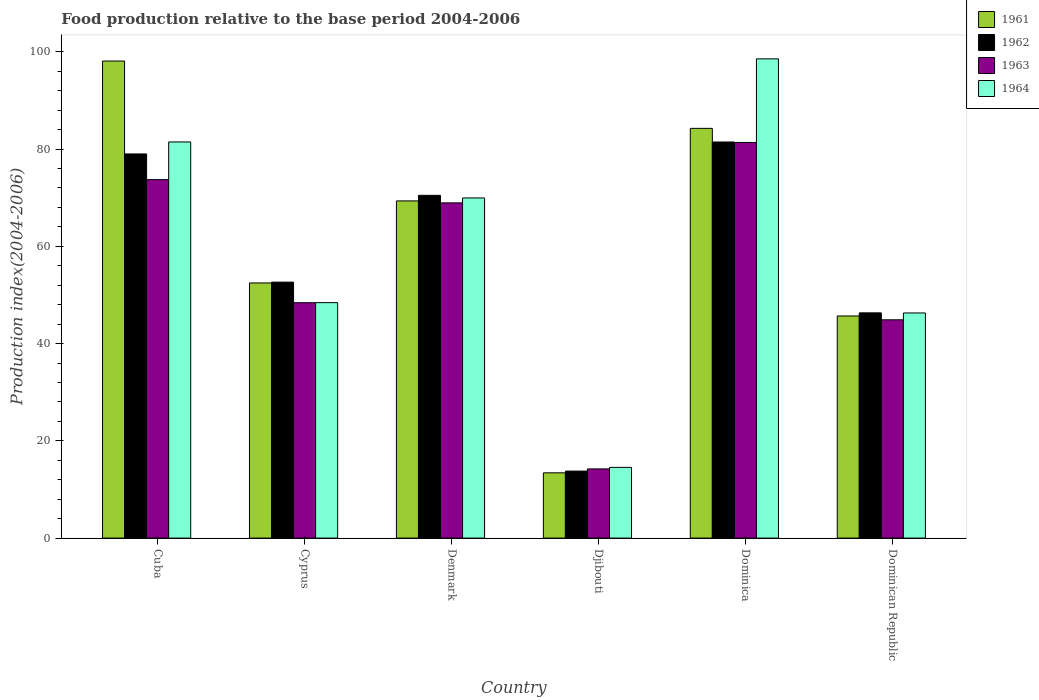How many groups of bars are there?
Offer a very short reply. 6. Are the number of bars per tick equal to the number of legend labels?
Provide a short and direct response. Yes. Are the number of bars on each tick of the X-axis equal?
Provide a short and direct response. Yes. How many bars are there on the 4th tick from the right?
Make the answer very short. 4. What is the label of the 1st group of bars from the left?
Offer a terse response. Cuba. In how many cases, is the number of bars for a given country not equal to the number of legend labels?
Provide a short and direct response. 0. What is the food production index in 1964 in Dominican Republic?
Your answer should be compact. 46.3. Across all countries, what is the maximum food production index in 1962?
Offer a terse response. 81.46. Across all countries, what is the minimum food production index in 1962?
Ensure brevity in your answer.  13.78. In which country was the food production index in 1964 maximum?
Offer a terse response. Dominica. In which country was the food production index in 1961 minimum?
Provide a short and direct response. Djibouti. What is the total food production index in 1962 in the graph?
Your answer should be very brief. 343.69. What is the difference between the food production index in 1961 in Cuba and that in Djibouti?
Your answer should be compact. 84.69. What is the difference between the food production index in 1963 in Dominican Republic and the food production index in 1964 in Cuba?
Make the answer very short. -36.58. What is the average food production index in 1964 per country?
Make the answer very short. 59.87. What is the difference between the food production index of/in 1962 and food production index of/in 1961 in Dominican Republic?
Offer a terse response. 0.64. In how many countries, is the food production index in 1961 greater than 96?
Your answer should be compact. 1. What is the ratio of the food production index in 1963 in Cuba to that in Djibouti?
Ensure brevity in your answer.  5.18. Is the food production index in 1963 in Denmark less than that in Djibouti?
Provide a short and direct response. No. What is the difference between the highest and the second highest food production index in 1962?
Offer a very short reply. 10.97. What is the difference between the highest and the lowest food production index in 1964?
Provide a short and direct response. 84.02. Is it the case that in every country, the sum of the food production index in 1961 and food production index in 1963 is greater than the sum of food production index in 1964 and food production index in 1962?
Your response must be concise. No. Is it the case that in every country, the sum of the food production index in 1964 and food production index in 1961 is greater than the food production index in 1963?
Offer a very short reply. Yes. How many countries are there in the graph?
Your answer should be compact. 6. What is the difference between two consecutive major ticks on the Y-axis?
Ensure brevity in your answer.  20. Are the values on the major ticks of Y-axis written in scientific E-notation?
Offer a very short reply. No. How are the legend labels stacked?
Offer a very short reply. Vertical. What is the title of the graph?
Provide a succinct answer. Food production relative to the base period 2004-2006. Does "1990" appear as one of the legend labels in the graph?
Offer a terse response. No. What is the label or title of the X-axis?
Make the answer very short. Country. What is the label or title of the Y-axis?
Offer a terse response. Production index(2004-2006). What is the Production index(2004-2006) in 1961 in Cuba?
Make the answer very short. 98.11. What is the Production index(2004-2006) in 1962 in Cuba?
Provide a succinct answer. 79. What is the Production index(2004-2006) in 1963 in Cuba?
Offer a terse response. 73.72. What is the Production index(2004-2006) in 1964 in Cuba?
Offer a very short reply. 81.47. What is the Production index(2004-2006) in 1961 in Cyprus?
Give a very brief answer. 52.47. What is the Production index(2004-2006) of 1962 in Cyprus?
Provide a short and direct response. 52.64. What is the Production index(2004-2006) of 1963 in Cyprus?
Make the answer very short. 48.41. What is the Production index(2004-2006) of 1964 in Cyprus?
Your response must be concise. 48.42. What is the Production index(2004-2006) in 1961 in Denmark?
Give a very brief answer. 69.34. What is the Production index(2004-2006) of 1962 in Denmark?
Make the answer very short. 70.49. What is the Production index(2004-2006) in 1963 in Denmark?
Offer a very short reply. 68.94. What is the Production index(2004-2006) in 1964 in Denmark?
Provide a succinct answer. 69.95. What is the Production index(2004-2006) in 1961 in Djibouti?
Make the answer very short. 13.42. What is the Production index(2004-2006) in 1962 in Djibouti?
Give a very brief answer. 13.78. What is the Production index(2004-2006) in 1963 in Djibouti?
Offer a very short reply. 14.23. What is the Production index(2004-2006) in 1964 in Djibouti?
Provide a short and direct response. 14.54. What is the Production index(2004-2006) in 1961 in Dominica?
Ensure brevity in your answer.  84.26. What is the Production index(2004-2006) in 1962 in Dominica?
Make the answer very short. 81.46. What is the Production index(2004-2006) of 1963 in Dominica?
Ensure brevity in your answer.  81.36. What is the Production index(2004-2006) in 1964 in Dominica?
Keep it short and to the point. 98.56. What is the Production index(2004-2006) of 1961 in Dominican Republic?
Give a very brief answer. 45.68. What is the Production index(2004-2006) in 1962 in Dominican Republic?
Provide a succinct answer. 46.32. What is the Production index(2004-2006) in 1963 in Dominican Republic?
Give a very brief answer. 44.89. What is the Production index(2004-2006) of 1964 in Dominican Republic?
Give a very brief answer. 46.3. Across all countries, what is the maximum Production index(2004-2006) in 1961?
Your answer should be very brief. 98.11. Across all countries, what is the maximum Production index(2004-2006) in 1962?
Your answer should be compact. 81.46. Across all countries, what is the maximum Production index(2004-2006) in 1963?
Provide a short and direct response. 81.36. Across all countries, what is the maximum Production index(2004-2006) in 1964?
Offer a very short reply. 98.56. Across all countries, what is the minimum Production index(2004-2006) in 1961?
Keep it short and to the point. 13.42. Across all countries, what is the minimum Production index(2004-2006) of 1962?
Ensure brevity in your answer.  13.78. Across all countries, what is the minimum Production index(2004-2006) of 1963?
Keep it short and to the point. 14.23. Across all countries, what is the minimum Production index(2004-2006) in 1964?
Your answer should be compact. 14.54. What is the total Production index(2004-2006) in 1961 in the graph?
Make the answer very short. 363.28. What is the total Production index(2004-2006) in 1962 in the graph?
Make the answer very short. 343.69. What is the total Production index(2004-2006) in 1963 in the graph?
Your answer should be compact. 331.55. What is the total Production index(2004-2006) of 1964 in the graph?
Offer a terse response. 359.24. What is the difference between the Production index(2004-2006) in 1961 in Cuba and that in Cyprus?
Keep it short and to the point. 45.64. What is the difference between the Production index(2004-2006) in 1962 in Cuba and that in Cyprus?
Ensure brevity in your answer.  26.36. What is the difference between the Production index(2004-2006) of 1963 in Cuba and that in Cyprus?
Ensure brevity in your answer.  25.31. What is the difference between the Production index(2004-2006) of 1964 in Cuba and that in Cyprus?
Offer a terse response. 33.05. What is the difference between the Production index(2004-2006) of 1961 in Cuba and that in Denmark?
Offer a terse response. 28.77. What is the difference between the Production index(2004-2006) in 1962 in Cuba and that in Denmark?
Provide a short and direct response. 8.51. What is the difference between the Production index(2004-2006) of 1963 in Cuba and that in Denmark?
Ensure brevity in your answer.  4.78. What is the difference between the Production index(2004-2006) in 1964 in Cuba and that in Denmark?
Make the answer very short. 11.52. What is the difference between the Production index(2004-2006) of 1961 in Cuba and that in Djibouti?
Your response must be concise. 84.69. What is the difference between the Production index(2004-2006) of 1962 in Cuba and that in Djibouti?
Your response must be concise. 65.22. What is the difference between the Production index(2004-2006) of 1963 in Cuba and that in Djibouti?
Your response must be concise. 59.49. What is the difference between the Production index(2004-2006) in 1964 in Cuba and that in Djibouti?
Offer a very short reply. 66.93. What is the difference between the Production index(2004-2006) in 1961 in Cuba and that in Dominica?
Offer a terse response. 13.85. What is the difference between the Production index(2004-2006) of 1962 in Cuba and that in Dominica?
Your answer should be compact. -2.46. What is the difference between the Production index(2004-2006) of 1963 in Cuba and that in Dominica?
Make the answer very short. -7.64. What is the difference between the Production index(2004-2006) of 1964 in Cuba and that in Dominica?
Your answer should be very brief. -17.09. What is the difference between the Production index(2004-2006) of 1961 in Cuba and that in Dominican Republic?
Provide a short and direct response. 52.43. What is the difference between the Production index(2004-2006) of 1962 in Cuba and that in Dominican Republic?
Keep it short and to the point. 32.68. What is the difference between the Production index(2004-2006) in 1963 in Cuba and that in Dominican Republic?
Make the answer very short. 28.83. What is the difference between the Production index(2004-2006) of 1964 in Cuba and that in Dominican Republic?
Your answer should be compact. 35.17. What is the difference between the Production index(2004-2006) of 1961 in Cyprus and that in Denmark?
Make the answer very short. -16.87. What is the difference between the Production index(2004-2006) of 1962 in Cyprus and that in Denmark?
Your answer should be very brief. -17.85. What is the difference between the Production index(2004-2006) of 1963 in Cyprus and that in Denmark?
Ensure brevity in your answer.  -20.53. What is the difference between the Production index(2004-2006) in 1964 in Cyprus and that in Denmark?
Offer a terse response. -21.53. What is the difference between the Production index(2004-2006) in 1961 in Cyprus and that in Djibouti?
Ensure brevity in your answer.  39.05. What is the difference between the Production index(2004-2006) in 1962 in Cyprus and that in Djibouti?
Give a very brief answer. 38.86. What is the difference between the Production index(2004-2006) of 1963 in Cyprus and that in Djibouti?
Keep it short and to the point. 34.18. What is the difference between the Production index(2004-2006) of 1964 in Cyprus and that in Djibouti?
Your answer should be compact. 33.88. What is the difference between the Production index(2004-2006) in 1961 in Cyprus and that in Dominica?
Keep it short and to the point. -31.79. What is the difference between the Production index(2004-2006) of 1962 in Cyprus and that in Dominica?
Provide a short and direct response. -28.82. What is the difference between the Production index(2004-2006) in 1963 in Cyprus and that in Dominica?
Your answer should be very brief. -32.95. What is the difference between the Production index(2004-2006) of 1964 in Cyprus and that in Dominica?
Keep it short and to the point. -50.14. What is the difference between the Production index(2004-2006) of 1961 in Cyprus and that in Dominican Republic?
Your answer should be compact. 6.79. What is the difference between the Production index(2004-2006) in 1962 in Cyprus and that in Dominican Republic?
Give a very brief answer. 6.32. What is the difference between the Production index(2004-2006) in 1963 in Cyprus and that in Dominican Republic?
Your answer should be very brief. 3.52. What is the difference between the Production index(2004-2006) in 1964 in Cyprus and that in Dominican Republic?
Your response must be concise. 2.12. What is the difference between the Production index(2004-2006) in 1961 in Denmark and that in Djibouti?
Provide a short and direct response. 55.92. What is the difference between the Production index(2004-2006) in 1962 in Denmark and that in Djibouti?
Provide a succinct answer. 56.71. What is the difference between the Production index(2004-2006) in 1963 in Denmark and that in Djibouti?
Offer a terse response. 54.71. What is the difference between the Production index(2004-2006) of 1964 in Denmark and that in Djibouti?
Offer a terse response. 55.41. What is the difference between the Production index(2004-2006) in 1961 in Denmark and that in Dominica?
Make the answer very short. -14.92. What is the difference between the Production index(2004-2006) in 1962 in Denmark and that in Dominica?
Provide a succinct answer. -10.97. What is the difference between the Production index(2004-2006) of 1963 in Denmark and that in Dominica?
Offer a terse response. -12.42. What is the difference between the Production index(2004-2006) of 1964 in Denmark and that in Dominica?
Your response must be concise. -28.61. What is the difference between the Production index(2004-2006) in 1961 in Denmark and that in Dominican Republic?
Keep it short and to the point. 23.66. What is the difference between the Production index(2004-2006) in 1962 in Denmark and that in Dominican Republic?
Keep it short and to the point. 24.17. What is the difference between the Production index(2004-2006) of 1963 in Denmark and that in Dominican Republic?
Offer a terse response. 24.05. What is the difference between the Production index(2004-2006) in 1964 in Denmark and that in Dominican Republic?
Offer a very short reply. 23.65. What is the difference between the Production index(2004-2006) of 1961 in Djibouti and that in Dominica?
Provide a short and direct response. -70.84. What is the difference between the Production index(2004-2006) of 1962 in Djibouti and that in Dominica?
Ensure brevity in your answer.  -67.68. What is the difference between the Production index(2004-2006) in 1963 in Djibouti and that in Dominica?
Make the answer very short. -67.13. What is the difference between the Production index(2004-2006) in 1964 in Djibouti and that in Dominica?
Your answer should be very brief. -84.02. What is the difference between the Production index(2004-2006) of 1961 in Djibouti and that in Dominican Republic?
Provide a succinct answer. -32.26. What is the difference between the Production index(2004-2006) in 1962 in Djibouti and that in Dominican Republic?
Your response must be concise. -32.54. What is the difference between the Production index(2004-2006) in 1963 in Djibouti and that in Dominican Republic?
Ensure brevity in your answer.  -30.66. What is the difference between the Production index(2004-2006) of 1964 in Djibouti and that in Dominican Republic?
Make the answer very short. -31.76. What is the difference between the Production index(2004-2006) in 1961 in Dominica and that in Dominican Republic?
Ensure brevity in your answer.  38.58. What is the difference between the Production index(2004-2006) of 1962 in Dominica and that in Dominican Republic?
Give a very brief answer. 35.14. What is the difference between the Production index(2004-2006) of 1963 in Dominica and that in Dominican Republic?
Your response must be concise. 36.47. What is the difference between the Production index(2004-2006) of 1964 in Dominica and that in Dominican Republic?
Your answer should be very brief. 52.26. What is the difference between the Production index(2004-2006) of 1961 in Cuba and the Production index(2004-2006) of 1962 in Cyprus?
Offer a very short reply. 45.47. What is the difference between the Production index(2004-2006) of 1961 in Cuba and the Production index(2004-2006) of 1963 in Cyprus?
Provide a short and direct response. 49.7. What is the difference between the Production index(2004-2006) of 1961 in Cuba and the Production index(2004-2006) of 1964 in Cyprus?
Give a very brief answer. 49.69. What is the difference between the Production index(2004-2006) in 1962 in Cuba and the Production index(2004-2006) in 1963 in Cyprus?
Provide a succinct answer. 30.59. What is the difference between the Production index(2004-2006) of 1962 in Cuba and the Production index(2004-2006) of 1964 in Cyprus?
Make the answer very short. 30.58. What is the difference between the Production index(2004-2006) of 1963 in Cuba and the Production index(2004-2006) of 1964 in Cyprus?
Ensure brevity in your answer.  25.3. What is the difference between the Production index(2004-2006) of 1961 in Cuba and the Production index(2004-2006) of 1962 in Denmark?
Give a very brief answer. 27.62. What is the difference between the Production index(2004-2006) in 1961 in Cuba and the Production index(2004-2006) in 1963 in Denmark?
Keep it short and to the point. 29.17. What is the difference between the Production index(2004-2006) in 1961 in Cuba and the Production index(2004-2006) in 1964 in Denmark?
Provide a short and direct response. 28.16. What is the difference between the Production index(2004-2006) in 1962 in Cuba and the Production index(2004-2006) in 1963 in Denmark?
Give a very brief answer. 10.06. What is the difference between the Production index(2004-2006) in 1962 in Cuba and the Production index(2004-2006) in 1964 in Denmark?
Your response must be concise. 9.05. What is the difference between the Production index(2004-2006) of 1963 in Cuba and the Production index(2004-2006) of 1964 in Denmark?
Provide a short and direct response. 3.77. What is the difference between the Production index(2004-2006) of 1961 in Cuba and the Production index(2004-2006) of 1962 in Djibouti?
Your answer should be compact. 84.33. What is the difference between the Production index(2004-2006) of 1961 in Cuba and the Production index(2004-2006) of 1963 in Djibouti?
Ensure brevity in your answer.  83.88. What is the difference between the Production index(2004-2006) in 1961 in Cuba and the Production index(2004-2006) in 1964 in Djibouti?
Your answer should be compact. 83.57. What is the difference between the Production index(2004-2006) in 1962 in Cuba and the Production index(2004-2006) in 1963 in Djibouti?
Your answer should be compact. 64.77. What is the difference between the Production index(2004-2006) in 1962 in Cuba and the Production index(2004-2006) in 1964 in Djibouti?
Your answer should be very brief. 64.46. What is the difference between the Production index(2004-2006) of 1963 in Cuba and the Production index(2004-2006) of 1964 in Djibouti?
Your answer should be compact. 59.18. What is the difference between the Production index(2004-2006) of 1961 in Cuba and the Production index(2004-2006) of 1962 in Dominica?
Your answer should be compact. 16.65. What is the difference between the Production index(2004-2006) of 1961 in Cuba and the Production index(2004-2006) of 1963 in Dominica?
Ensure brevity in your answer.  16.75. What is the difference between the Production index(2004-2006) of 1961 in Cuba and the Production index(2004-2006) of 1964 in Dominica?
Your response must be concise. -0.45. What is the difference between the Production index(2004-2006) of 1962 in Cuba and the Production index(2004-2006) of 1963 in Dominica?
Your answer should be very brief. -2.36. What is the difference between the Production index(2004-2006) in 1962 in Cuba and the Production index(2004-2006) in 1964 in Dominica?
Your answer should be very brief. -19.56. What is the difference between the Production index(2004-2006) of 1963 in Cuba and the Production index(2004-2006) of 1964 in Dominica?
Your answer should be very brief. -24.84. What is the difference between the Production index(2004-2006) in 1961 in Cuba and the Production index(2004-2006) in 1962 in Dominican Republic?
Your response must be concise. 51.79. What is the difference between the Production index(2004-2006) in 1961 in Cuba and the Production index(2004-2006) in 1963 in Dominican Republic?
Give a very brief answer. 53.22. What is the difference between the Production index(2004-2006) in 1961 in Cuba and the Production index(2004-2006) in 1964 in Dominican Republic?
Make the answer very short. 51.81. What is the difference between the Production index(2004-2006) in 1962 in Cuba and the Production index(2004-2006) in 1963 in Dominican Republic?
Ensure brevity in your answer.  34.11. What is the difference between the Production index(2004-2006) of 1962 in Cuba and the Production index(2004-2006) of 1964 in Dominican Republic?
Give a very brief answer. 32.7. What is the difference between the Production index(2004-2006) in 1963 in Cuba and the Production index(2004-2006) in 1964 in Dominican Republic?
Ensure brevity in your answer.  27.42. What is the difference between the Production index(2004-2006) in 1961 in Cyprus and the Production index(2004-2006) in 1962 in Denmark?
Your answer should be compact. -18.02. What is the difference between the Production index(2004-2006) in 1961 in Cyprus and the Production index(2004-2006) in 1963 in Denmark?
Your response must be concise. -16.47. What is the difference between the Production index(2004-2006) of 1961 in Cyprus and the Production index(2004-2006) of 1964 in Denmark?
Provide a succinct answer. -17.48. What is the difference between the Production index(2004-2006) in 1962 in Cyprus and the Production index(2004-2006) in 1963 in Denmark?
Ensure brevity in your answer.  -16.3. What is the difference between the Production index(2004-2006) of 1962 in Cyprus and the Production index(2004-2006) of 1964 in Denmark?
Your answer should be compact. -17.31. What is the difference between the Production index(2004-2006) in 1963 in Cyprus and the Production index(2004-2006) in 1964 in Denmark?
Offer a terse response. -21.54. What is the difference between the Production index(2004-2006) in 1961 in Cyprus and the Production index(2004-2006) in 1962 in Djibouti?
Your response must be concise. 38.69. What is the difference between the Production index(2004-2006) in 1961 in Cyprus and the Production index(2004-2006) in 1963 in Djibouti?
Make the answer very short. 38.24. What is the difference between the Production index(2004-2006) of 1961 in Cyprus and the Production index(2004-2006) of 1964 in Djibouti?
Ensure brevity in your answer.  37.93. What is the difference between the Production index(2004-2006) of 1962 in Cyprus and the Production index(2004-2006) of 1963 in Djibouti?
Provide a short and direct response. 38.41. What is the difference between the Production index(2004-2006) of 1962 in Cyprus and the Production index(2004-2006) of 1964 in Djibouti?
Give a very brief answer. 38.1. What is the difference between the Production index(2004-2006) of 1963 in Cyprus and the Production index(2004-2006) of 1964 in Djibouti?
Offer a very short reply. 33.87. What is the difference between the Production index(2004-2006) of 1961 in Cyprus and the Production index(2004-2006) of 1962 in Dominica?
Your answer should be very brief. -28.99. What is the difference between the Production index(2004-2006) in 1961 in Cyprus and the Production index(2004-2006) in 1963 in Dominica?
Your answer should be very brief. -28.89. What is the difference between the Production index(2004-2006) in 1961 in Cyprus and the Production index(2004-2006) in 1964 in Dominica?
Your response must be concise. -46.09. What is the difference between the Production index(2004-2006) of 1962 in Cyprus and the Production index(2004-2006) of 1963 in Dominica?
Your response must be concise. -28.72. What is the difference between the Production index(2004-2006) in 1962 in Cyprus and the Production index(2004-2006) in 1964 in Dominica?
Provide a short and direct response. -45.92. What is the difference between the Production index(2004-2006) in 1963 in Cyprus and the Production index(2004-2006) in 1964 in Dominica?
Your answer should be very brief. -50.15. What is the difference between the Production index(2004-2006) in 1961 in Cyprus and the Production index(2004-2006) in 1962 in Dominican Republic?
Your response must be concise. 6.15. What is the difference between the Production index(2004-2006) of 1961 in Cyprus and the Production index(2004-2006) of 1963 in Dominican Republic?
Your answer should be compact. 7.58. What is the difference between the Production index(2004-2006) of 1961 in Cyprus and the Production index(2004-2006) of 1964 in Dominican Republic?
Ensure brevity in your answer.  6.17. What is the difference between the Production index(2004-2006) in 1962 in Cyprus and the Production index(2004-2006) in 1963 in Dominican Republic?
Offer a terse response. 7.75. What is the difference between the Production index(2004-2006) in 1962 in Cyprus and the Production index(2004-2006) in 1964 in Dominican Republic?
Ensure brevity in your answer.  6.34. What is the difference between the Production index(2004-2006) in 1963 in Cyprus and the Production index(2004-2006) in 1964 in Dominican Republic?
Your answer should be compact. 2.11. What is the difference between the Production index(2004-2006) of 1961 in Denmark and the Production index(2004-2006) of 1962 in Djibouti?
Your answer should be very brief. 55.56. What is the difference between the Production index(2004-2006) in 1961 in Denmark and the Production index(2004-2006) in 1963 in Djibouti?
Your answer should be compact. 55.11. What is the difference between the Production index(2004-2006) of 1961 in Denmark and the Production index(2004-2006) of 1964 in Djibouti?
Provide a succinct answer. 54.8. What is the difference between the Production index(2004-2006) in 1962 in Denmark and the Production index(2004-2006) in 1963 in Djibouti?
Your answer should be very brief. 56.26. What is the difference between the Production index(2004-2006) of 1962 in Denmark and the Production index(2004-2006) of 1964 in Djibouti?
Your answer should be very brief. 55.95. What is the difference between the Production index(2004-2006) in 1963 in Denmark and the Production index(2004-2006) in 1964 in Djibouti?
Provide a short and direct response. 54.4. What is the difference between the Production index(2004-2006) in 1961 in Denmark and the Production index(2004-2006) in 1962 in Dominica?
Your response must be concise. -12.12. What is the difference between the Production index(2004-2006) in 1961 in Denmark and the Production index(2004-2006) in 1963 in Dominica?
Make the answer very short. -12.02. What is the difference between the Production index(2004-2006) of 1961 in Denmark and the Production index(2004-2006) of 1964 in Dominica?
Give a very brief answer. -29.22. What is the difference between the Production index(2004-2006) in 1962 in Denmark and the Production index(2004-2006) in 1963 in Dominica?
Keep it short and to the point. -10.87. What is the difference between the Production index(2004-2006) in 1962 in Denmark and the Production index(2004-2006) in 1964 in Dominica?
Offer a very short reply. -28.07. What is the difference between the Production index(2004-2006) in 1963 in Denmark and the Production index(2004-2006) in 1964 in Dominica?
Ensure brevity in your answer.  -29.62. What is the difference between the Production index(2004-2006) in 1961 in Denmark and the Production index(2004-2006) in 1962 in Dominican Republic?
Your response must be concise. 23.02. What is the difference between the Production index(2004-2006) in 1961 in Denmark and the Production index(2004-2006) in 1963 in Dominican Republic?
Ensure brevity in your answer.  24.45. What is the difference between the Production index(2004-2006) in 1961 in Denmark and the Production index(2004-2006) in 1964 in Dominican Republic?
Your response must be concise. 23.04. What is the difference between the Production index(2004-2006) of 1962 in Denmark and the Production index(2004-2006) of 1963 in Dominican Republic?
Make the answer very short. 25.6. What is the difference between the Production index(2004-2006) of 1962 in Denmark and the Production index(2004-2006) of 1964 in Dominican Republic?
Offer a very short reply. 24.19. What is the difference between the Production index(2004-2006) in 1963 in Denmark and the Production index(2004-2006) in 1964 in Dominican Republic?
Your answer should be very brief. 22.64. What is the difference between the Production index(2004-2006) of 1961 in Djibouti and the Production index(2004-2006) of 1962 in Dominica?
Offer a terse response. -68.04. What is the difference between the Production index(2004-2006) of 1961 in Djibouti and the Production index(2004-2006) of 1963 in Dominica?
Make the answer very short. -67.94. What is the difference between the Production index(2004-2006) in 1961 in Djibouti and the Production index(2004-2006) in 1964 in Dominica?
Offer a very short reply. -85.14. What is the difference between the Production index(2004-2006) of 1962 in Djibouti and the Production index(2004-2006) of 1963 in Dominica?
Make the answer very short. -67.58. What is the difference between the Production index(2004-2006) of 1962 in Djibouti and the Production index(2004-2006) of 1964 in Dominica?
Your answer should be compact. -84.78. What is the difference between the Production index(2004-2006) in 1963 in Djibouti and the Production index(2004-2006) in 1964 in Dominica?
Give a very brief answer. -84.33. What is the difference between the Production index(2004-2006) of 1961 in Djibouti and the Production index(2004-2006) of 1962 in Dominican Republic?
Your answer should be very brief. -32.9. What is the difference between the Production index(2004-2006) of 1961 in Djibouti and the Production index(2004-2006) of 1963 in Dominican Republic?
Provide a short and direct response. -31.47. What is the difference between the Production index(2004-2006) in 1961 in Djibouti and the Production index(2004-2006) in 1964 in Dominican Republic?
Your answer should be very brief. -32.88. What is the difference between the Production index(2004-2006) in 1962 in Djibouti and the Production index(2004-2006) in 1963 in Dominican Republic?
Your answer should be very brief. -31.11. What is the difference between the Production index(2004-2006) of 1962 in Djibouti and the Production index(2004-2006) of 1964 in Dominican Republic?
Make the answer very short. -32.52. What is the difference between the Production index(2004-2006) in 1963 in Djibouti and the Production index(2004-2006) in 1964 in Dominican Republic?
Provide a short and direct response. -32.07. What is the difference between the Production index(2004-2006) in 1961 in Dominica and the Production index(2004-2006) in 1962 in Dominican Republic?
Provide a succinct answer. 37.94. What is the difference between the Production index(2004-2006) of 1961 in Dominica and the Production index(2004-2006) of 1963 in Dominican Republic?
Your answer should be very brief. 39.37. What is the difference between the Production index(2004-2006) in 1961 in Dominica and the Production index(2004-2006) in 1964 in Dominican Republic?
Your answer should be compact. 37.96. What is the difference between the Production index(2004-2006) in 1962 in Dominica and the Production index(2004-2006) in 1963 in Dominican Republic?
Keep it short and to the point. 36.57. What is the difference between the Production index(2004-2006) in 1962 in Dominica and the Production index(2004-2006) in 1964 in Dominican Republic?
Make the answer very short. 35.16. What is the difference between the Production index(2004-2006) of 1963 in Dominica and the Production index(2004-2006) of 1964 in Dominican Republic?
Your answer should be compact. 35.06. What is the average Production index(2004-2006) of 1961 per country?
Your answer should be compact. 60.55. What is the average Production index(2004-2006) in 1962 per country?
Offer a very short reply. 57.28. What is the average Production index(2004-2006) in 1963 per country?
Your response must be concise. 55.26. What is the average Production index(2004-2006) in 1964 per country?
Offer a very short reply. 59.87. What is the difference between the Production index(2004-2006) of 1961 and Production index(2004-2006) of 1962 in Cuba?
Provide a short and direct response. 19.11. What is the difference between the Production index(2004-2006) in 1961 and Production index(2004-2006) in 1963 in Cuba?
Provide a short and direct response. 24.39. What is the difference between the Production index(2004-2006) of 1961 and Production index(2004-2006) of 1964 in Cuba?
Your answer should be compact. 16.64. What is the difference between the Production index(2004-2006) in 1962 and Production index(2004-2006) in 1963 in Cuba?
Your answer should be very brief. 5.28. What is the difference between the Production index(2004-2006) of 1962 and Production index(2004-2006) of 1964 in Cuba?
Make the answer very short. -2.47. What is the difference between the Production index(2004-2006) of 1963 and Production index(2004-2006) of 1964 in Cuba?
Offer a terse response. -7.75. What is the difference between the Production index(2004-2006) in 1961 and Production index(2004-2006) in 1962 in Cyprus?
Give a very brief answer. -0.17. What is the difference between the Production index(2004-2006) in 1961 and Production index(2004-2006) in 1963 in Cyprus?
Ensure brevity in your answer.  4.06. What is the difference between the Production index(2004-2006) of 1961 and Production index(2004-2006) of 1964 in Cyprus?
Provide a short and direct response. 4.05. What is the difference between the Production index(2004-2006) of 1962 and Production index(2004-2006) of 1963 in Cyprus?
Make the answer very short. 4.23. What is the difference between the Production index(2004-2006) in 1962 and Production index(2004-2006) in 1964 in Cyprus?
Your answer should be very brief. 4.22. What is the difference between the Production index(2004-2006) in 1963 and Production index(2004-2006) in 1964 in Cyprus?
Keep it short and to the point. -0.01. What is the difference between the Production index(2004-2006) in 1961 and Production index(2004-2006) in 1962 in Denmark?
Your answer should be compact. -1.15. What is the difference between the Production index(2004-2006) in 1961 and Production index(2004-2006) in 1963 in Denmark?
Offer a terse response. 0.4. What is the difference between the Production index(2004-2006) of 1961 and Production index(2004-2006) of 1964 in Denmark?
Your answer should be compact. -0.61. What is the difference between the Production index(2004-2006) of 1962 and Production index(2004-2006) of 1963 in Denmark?
Give a very brief answer. 1.55. What is the difference between the Production index(2004-2006) of 1962 and Production index(2004-2006) of 1964 in Denmark?
Offer a terse response. 0.54. What is the difference between the Production index(2004-2006) in 1963 and Production index(2004-2006) in 1964 in Denmark?
Your response must be concise. -1.01. What is the difference between the Production index(2004-2006) in 1961 and Production index(2004-2006) in 1962 in Djibouti?
Provide a succinct answer. -0.36. What is the difference between the Production index(2004-2006) of 1961 and Production index(2004-2006) of 1963 in Djibouti?
Make the answer very short. -0.81. What is the difference between the Production index(2004-2006) of 1961 and Production index(2004-2006) of 1964 in Djibouti?
Offer a terse response. -1.12. What is the difference between the Production index(2004-2006) in 1962 and Production index(2004-2006) in 1963 in Djibouti?
Keep it short and to the point. -0.45. What is the difference between the Production index(2004-2006) in 1962 and Production index(2004-2006) in 1964 in Djibouti?
Ensure brevity in your answer.  -0.76. What is the difference between the Production index(2004-2006) in 1963 and Production index(2004-2006) in 1964 in Djibouti?
Make the answer very short. -0.31. What is the difference between the Production index(2004-2006) in 1961 and Production index(2004-2006) in 1964 in Dominica?
Make the answer very short. -14.3. What is the difference between the Production index(2004-2006) of 1962 and Production index(2004-2006) of 1964 in Dominica?
Offer a terse response. -17.1. What is the difference between the Production index(2004-2006) in 1963 and Production index(2004-2006) in 1964 in Dominica?
Your response must be concise. -17.2. What is the difference between the Production index(2004-2006) in 1961 and Production index(2004-2006) in 1962 in Dominican Republic?
Ensure brevity in your answer.  -0.64. What is the difference between the Production index(2004-2006) in 1961 and Production index(2004-2006) in 1963 in Dominican Republic?
Your response must be concise. 0.79. What is the difference between the Production index(2004-2006) of 1961 and Production index(2004-2006) of 1964 in Dominican Republic?
Your answer should be very brief. -0.62. What is the difference between the Production index(2004-2006) in 1962 and Production index(2004-2006) in 1963 in Dominican Republic?
Provide a succinct answer. 1.43. What is the difference between the Production index(2004-2006) in 1963 and Production index(2004-2006) in 1964 in Dominican Republic?
Make the answer very short. -1.41. What is the ratio of the Production index(2004-2006) in 1961 in Cuba to that in Cyprus?
Provide a short and direct response. 1.87. What is the ratio of the Production index(2004-2006) of 1962 in Cuba to that in Cyprus?
Ensure brevity in your answer.  1.5. What is the ratio of the Production index(2004-2006) in 1963 in Cuba to that in Cyprus?
Offer a terse response. 1.52. What is the ratio of the Production index(2004-2006) of 1964 in Cuba to that in Cyprus?
Your response must be concise. 1.68. What is the ratio of the Production index(2004-2006) in 1961 in Cuba to that in Denmark?
Offer a terse response. 1.41. What is the ratio of the Production index(2004-2006) in 1962 in Cuba to that in Denmark?
Your response must be concise. 1.12. What is the ratio of the Production index(2004-2006) in 1963 in Cuba to that in Denmark?
Provide a succinct answer. 1.07. What is the ratio of the Production index(2004-2006) of 1964 in Cuba to that in Denmark?
Keep it short and to the point. 1.16. What is the ratio of the Production index(2004-2006) of 1961 in Cuba to that in Djibouti?
Offer a terse response. 7.31. What is the ratio of the Production index(2004-2006) in 1962 in Cuba to that in Djibouti?
Offer a very short reply. 5.73. What is the ratio of the Production index(2004-2006) in 1963 in Cuba to that in Djibouti?
Provide a short and direct response. 5.18. What is the ratio of the Production index(2004-2006) of 1964 in Cuba to that in Djibouti?
Give a very brief answer. 5.6. What is the ratio of the Production index(2004-2006) in 1961 in Cuba to that in Dominica?
Offer a very short reply. 1.16. What is the ratio of the Production index(2004-2006) of 1962 in Cuba to that in Dominica?
Keep it short and to the point. 0.97. What is the ratio of the Production index(2004-2006) of 1963 in Cuba to that in Dominica?
Provide a succinct answer. 0.91. What is the ratio of the Production index(2004-2006) of 1964 in Cuba to that in Dominica?
Ensure brevity in your answer.  0.83. What is the ratio of the Production index(2004-2006) of 1961 in Cuba to that in Dominican Republic?
Your answer should be compact. 2.15. What is the ratio of the Production index(2004-2006) of 1962 in Cuba to that in Dominican Republic?
Offer a terse response. 1.71. What is the ratio of the Production index(2004-2006) of 1963 in Cuba to that in Dominican Republic?
Ensure brevity in your answer.  1.64. What is the ratio of the Production index(2004-2006) in 1964 in Cuba to that in Dominican Republic?
Make the answer very short. 1.76. What is the ratio of the Production index(2004-2006) in 1961 in Cyprus to that in Denmark?
Your response must be concise. 0.76. What is the ratio of the Production index(2004-2006) of 1962 in Cyprus to that in Denmark?
Your answer should be compact. 0.75. What is the ratio of the Production index(2004-2006) of 1963 in Cyprus to that in Denmark?
Offer a terse response. 0.7. What is the ratio of the Production index(2004-2006) in 1964 in Cyprus to that in Denmark?
Provide a short and direct response. 0.69. What is the ratio of the Production index(2004-2006) in 1961 in Cyprus to that in Djibouti?
Make the answer very short. 3.91. What is the ratio of the Production index(2004-2006) of 1962 in Cyprus to that in Djibouti?
Your answer should be compact. 3.82. What is the ratio of the Production index(2004-2006) of 1963 in Cyprus to that in Djibouti?
Give a very brief answer. 3.4. What is the ratio of the Production index(2004-2006) of 1964 in Cyprus to that in Djibouti?
Provide a succinct answer. 3.33. What is the ratio of the Production index(2004-2006) of 1961 in Cyprus to that in Dominica?
Provide a short and direct response. 0.62. What is the ratio of the Production index(2004-2006) in 1962 in Cyprus to that in Dominica?
Ensure brevity in your answer.  0.65. What is the ratio of the Production index(2004-2006) in 1963 in Cyprus to that in Dominica?
Give a very brief answer. 0.59. What is the ratio of the Production index(2004-2006) in 1964 in Cyprus to that in Dominica?
Your answer should be compact. 0.49. What is the ratio of the Production index(2004-2006) of 1961 in Cyprus to that in Dominican Republic?
Offer a very short reply. 1.15. What is the ratio of the Production index(2004-2006) of 1962 in Cyprus to that in Dominican Republic?
Your answer should be compact. 1.14. What is the ratio of the Production index(2004-2006) in 1963 in Cyprus to that in Dominican Republic?
Provide a succinct answer. 1.08. What is the ratio of the Production index(2004-2006) in 1964 in Cyprus to that in Dominican Republic?
Offer a very short reply. 1.05. What is the ratio of the Production index(2004-2006) of 1961 in Denmark to that in Djibouti?
Make the answer very short. 5.17. What is the ratio of the Production index(2004-2006) in 1962 in Denmark to that in Djibouti?
Offer a terse response. 5.12. What is the ratio of the Production index(2004-2006) in 1963 in Denmark to that in Djibouti?
Your answer should be compact. 4.84. What is the ratio of the Production index(2004-2006) in 1964 in Denmark to that in Djibouti?
Ensure brevity in your answer.  4.81. What is the ratio of the Production index(2004-2006) in 1961 in Denmark to that in Dominica?
Offer a very short reply. 0.82. What is the ratio of the Production index(2004-2006) in 1962 in Denmark to that in Dominica?
Your response must be concise. 0.87. What is the ratio of the Production index(2004-2006) in 1963 in Denmark to that in Dominica?
Your response must be concise. 0.85. What is the ratio of the Production index(2004-2006) in 1964 in Denmark to that in Dominica?
Provide a succinct answer. 0.71. What is the ratio of the Production index(2004-2006) of 1961 in Denmark to that in Dominican Republic?
Keep it short and to the point. 1.52. What is the ratio of the Production index(2004-2006) of 1962 in Denmark to that in Dominican Republic?
Your response must be concise. 1.52. What is the ratio of the Production index(2004-2006) in 1963 in Denmark to that in Dominican Republic?
Give a very brief answer. 1.54. What is the ratio of the Production index(2004-2006) in 1964 in Denmark to that in Dominican Republic?
Make the answer very short. 1.51. What is the ratio of the Production index(2004-2006) of 1961 in Djibouti to that in Dominica?
Provide a succinct answer. 0.16. What is the ratio of the Production index(2004-2006) of 1962 in Djibouti to that in Dominica?
Make the answer very short. 0.17. What is the ratio of the Production index(2004-2006) of 1963 in Djibouti to that in Dominica?
Offer a terse response. 0.17. What is the ratio of the Production index(2004-2006) of 1964 in Djibouti to that in Dominica?
Your answer should be compact. 0.15. What is the ratio of the Production index(2004-2006) of 1961 in Djibouti to that in Dominican Republic?
Keep it short and to the point. 0.29. What is the ratio of the Production index(2004-2006) in 1962 in Djibouti to that in Dominican Republic?
Make the answer very short. 0.3. What is the ratio of the Production index(2004-2006) of 1963 in Djibouti to that in Dominican Republic?
Your answer should be compact. 0.32. What is the ratio of the Production index(2004-2006) of 1964 in Djibouti to that in Dominican Republic?
Keep it short and to the point. 0.31. What is the ratio of the Production index(2004-2006) in 1961 in Dominica to that in Dominican Republic?
Make the answer very short. 1.84. What is the ratio of the Production index(2004-2006) in 1962 in Dominica to that in Dominican Republic?
Your answer should be compact. 1.76. What is the ratio of the Production index(2004-2006) in 1963 in Dominica to that in Dominican Republic?
Provide a succinct answer. 1.81. What is the ratio of the Production index(2004-2006) in 1964 in Dominica to that in Dominican Republic?
Your response must be concise. 2.13. What is the difference between the highest and the second highest Production index(2004-2006) of 1961?
Offer a terse response. 13.85. What is the difference between the highest and the second highest Production index(2004-2006) in 1962?
Make the answer very short. 2.46. What is the difference between the highest and the second highest Production index(2004-2006) of 1963?
Ensure brevity in your answer.  7.64. What is the difference between the highest and the second highest Production index(2004-2006) of 1964?
Your response must be concise. 17.09. What is the difference between the highest and the lowest Production index(2004-2006) in 1961?
Provide a short and direct response. 84.69. What is the difference between the highest and the lowest Production index(2004-2006) in 1962?
Keep it short and to the point. 67.68. What is the difference between the highest and the lowest Production index(2004-2006) in 1963?
Provide a short and direct response. 67.13. What is the difference between the highest and the lowest Production index(2004-2006) of 1964?
Keep it short and to the point. 84.02. 